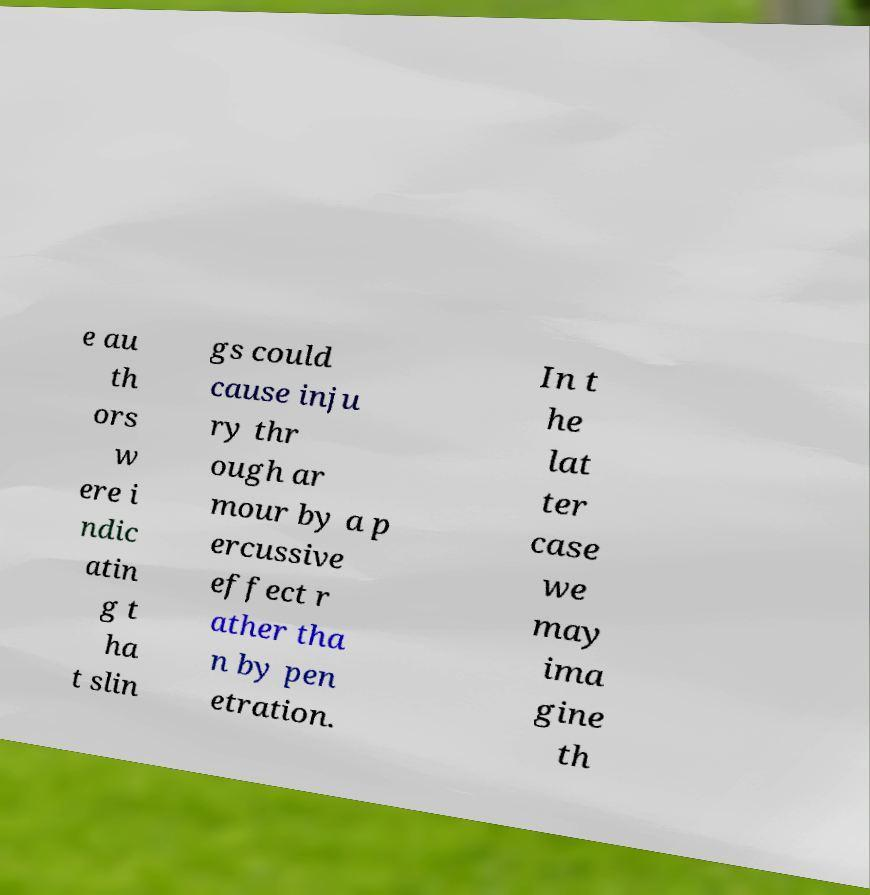Can you read and provide the text displayed in the image?This photo seems to have some interesting text. Can you extract and type it out for me? e au th ors w ere i ndic atin g t ha t slin gs could cause inju ry thr ough ar mour by a p ercussive effect r ather tha n by pen etration. In t he lat ter case we may ima gine th 